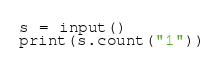<code> <loc_0><loc_0><loc_500><loc_500><_Python_>s = input()
print(s.count("1"))</code> 